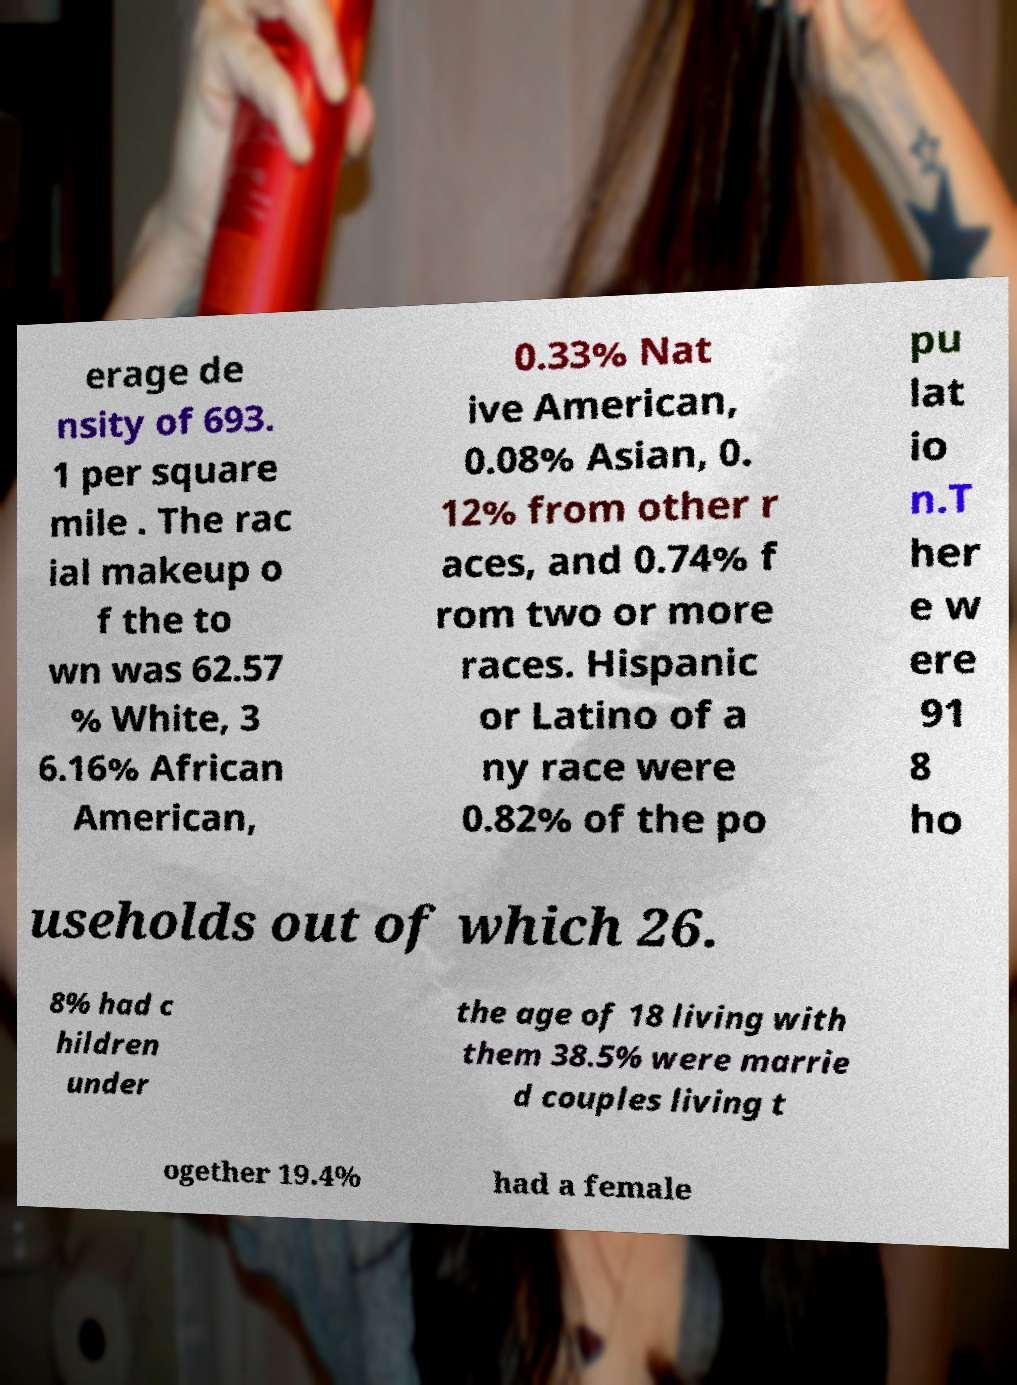Please identify and transcribe the text found in this image. erage de nsity of 693. 1 per square mile . The rac ial makeup o f the to wn was 62.57 % White, 3 6.16% African American, 0.33% Nat ive American, 0.08% Asian, 0. 12% from other r aces, and 0.74% f rom two or more races. Hispanic or Latino of a ny race were 0.82% of the po pu lat io n.T her e w ere 91 8 ho useholds out of which 26. 8% had c hildren under the age of 18 living with them 38.5% were marrie d couples living t ogether 19.4% had a female 